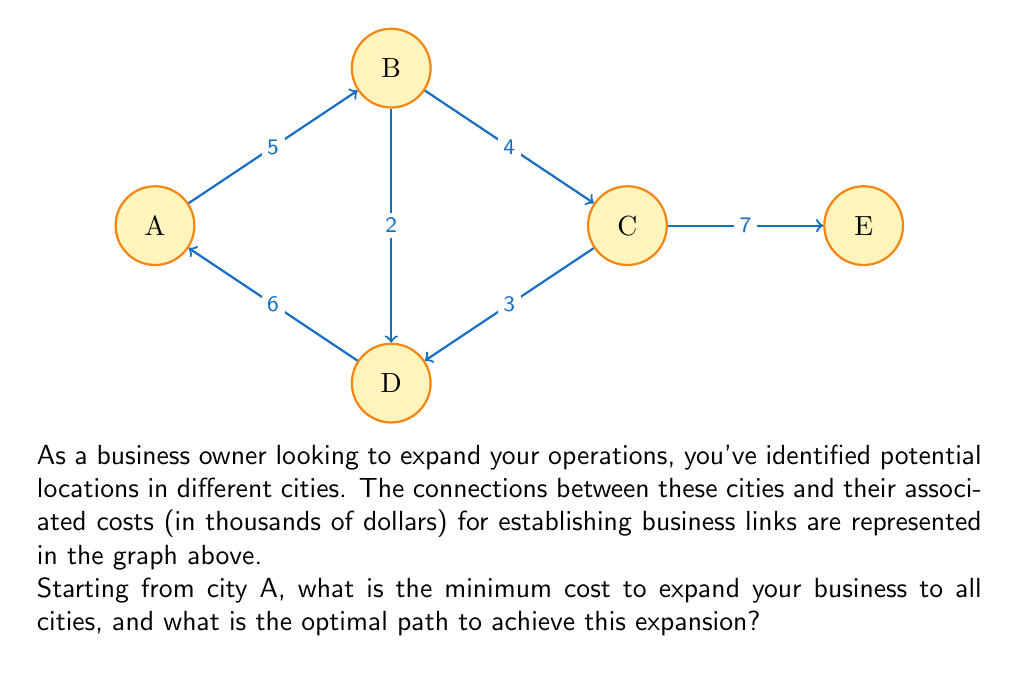Give your solution to this math problem. To solve this problem, we'll use Prim's algorithm to find the Minimum Spanning Tree (MST) of the graph. This will give us the optimal path for business expansion with the minimum total cost.

Step 1: Initialize the MST with the starting vertex A.

Step 2: Consider all edges connected to the vertices in the MST. Choose the edge with the minimum weight that connects a vertex in the MST to a vertex not in the MST.

- Edges from A: A-B (5), A-D (6)
- Choose A-B (5)

MST: A-B, Cost: 5

Step 3: Repeat step 2 until all vertices are included in the MST.

- Edges to consider: B-D (2), B-C (4), A-D (6)
- Choose B-D (2)

MST: A-B-D, Cost: 5 + 2 = 7

- Edges to consider: B-C (4), A-D (6), C-D (3)
- Choose C-D (3)

MST: A-B-D-C, Cost: 7 + 3 = 10

- Only edge left to consider: C-E (7)
- Add C-E (7)

Final MST: A-B-D-C-E, Total Cost: 10 + 7 = 17

The minimum cost to expand the business to all cities is $17,000.

The optimal path for expansion is:
A → B → D → C → E

This path ensures that each new expansion builds upon the existing network, minimizing the overall cost of establishing business links between all cities.
Answer: Minimum cost: $17,000. Optimal path: A → B → D → C → E. 